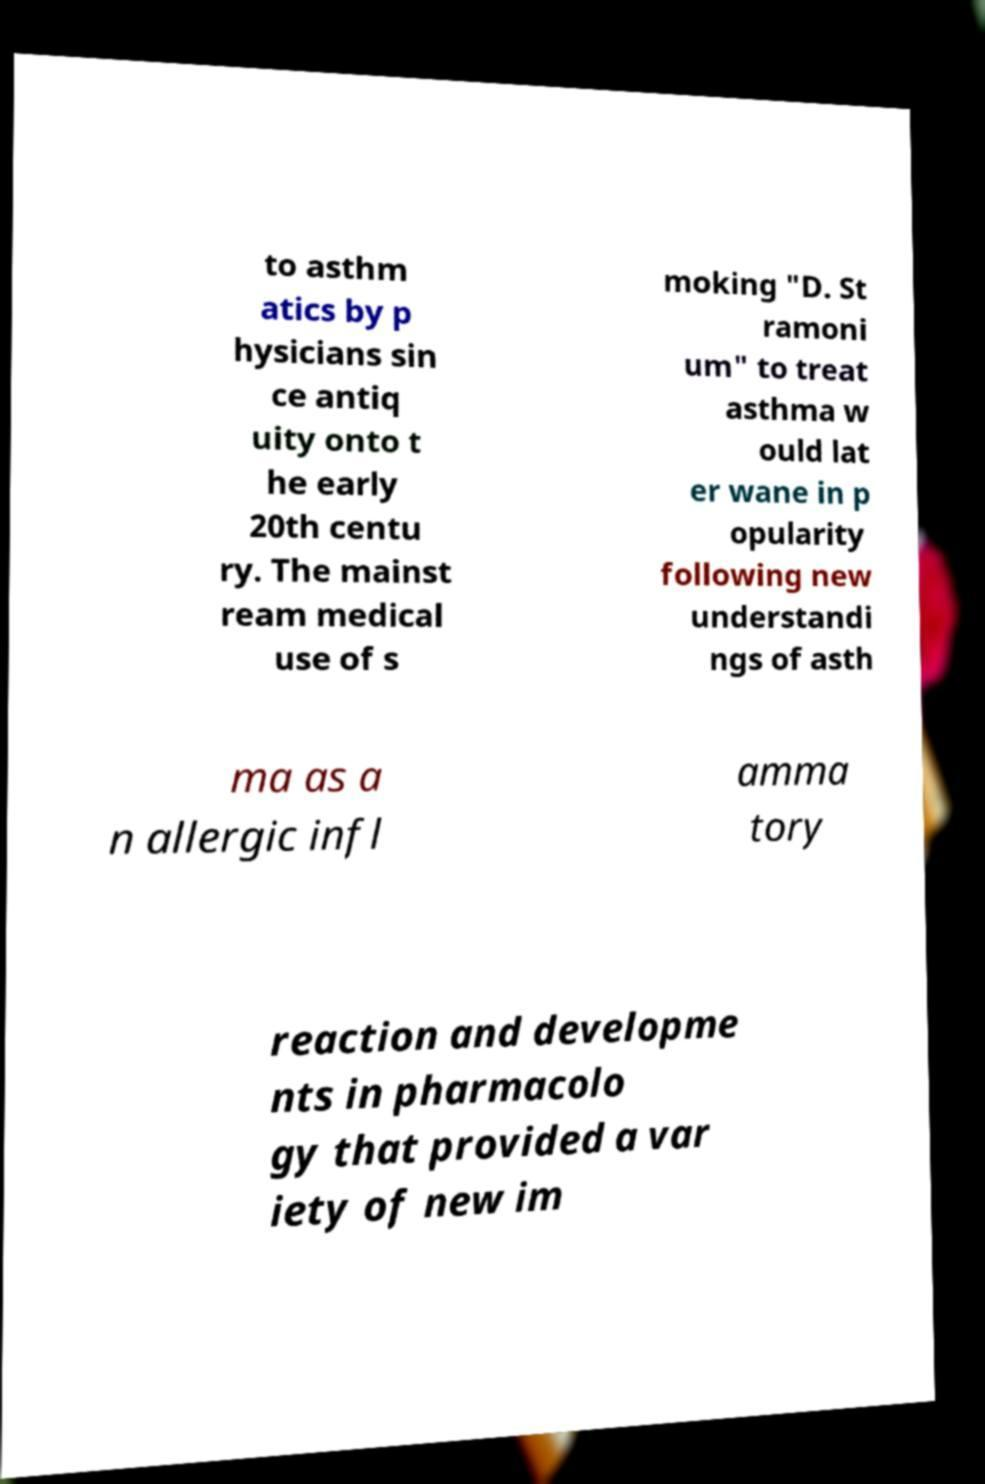Could you extract and type out the text from this image? to asthm atics by p hysicians sin ce antiq uity onto t he early 20th centu ry. The mainst ream medical use of s moking "D. St ramoni um" to treat asthma w ould lat er wane in p opularity following new understandi ngs of asth ma as a n allergic infl amma tory reaction and developme nts in pharmacolo gy that provided a var iety of new im 